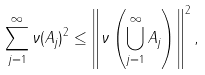<formula> <loc_0><loc_0><loc_500><loc_500>\sum _ { j = 1 } ^ { \infty } \| \nu ( A _ { j } ) \| ^ { 2 } \leq \left \| \nu \left ( \bigcup _ { j = 1 } ^ { \infty } A _ { j } \right ) \right \| ^ { 2 } ,</formula> 